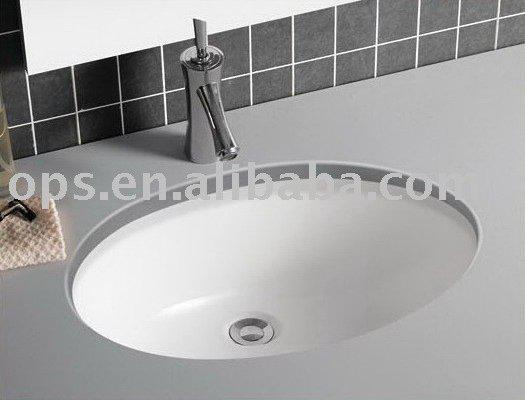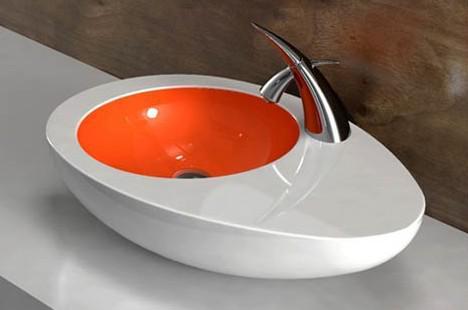The first image is the image on the left, the second image is the image on the right. Assess this claim about the two images: "The sink on the left is a circular shape with a white interior". Correct or not? Answer yes or no. Yes. The first image is the image on the left, the second image is the image on the right. Given the left and right images, does the statement "One sink has a round basin and features a two-tone design that includes a bright color." hold true? Answer yes or no. Yes. 